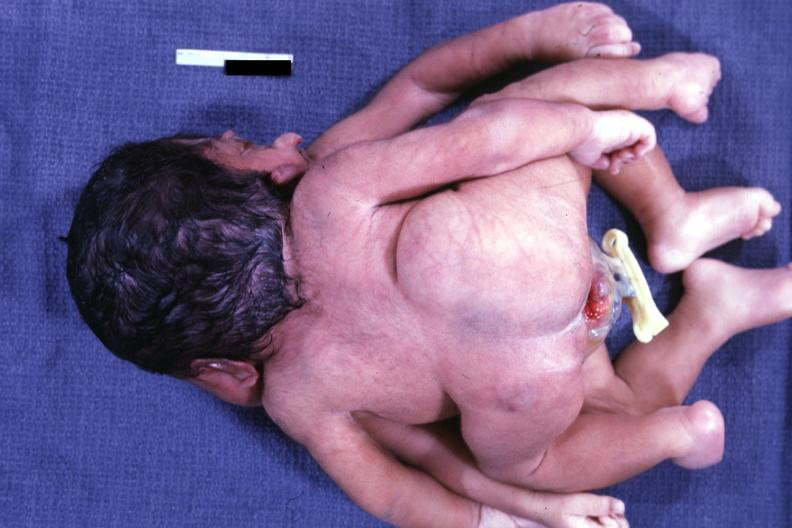what is present?
Answer the question using a single word or phrase. Conjoined twins cephalothoracopagus janiceps 